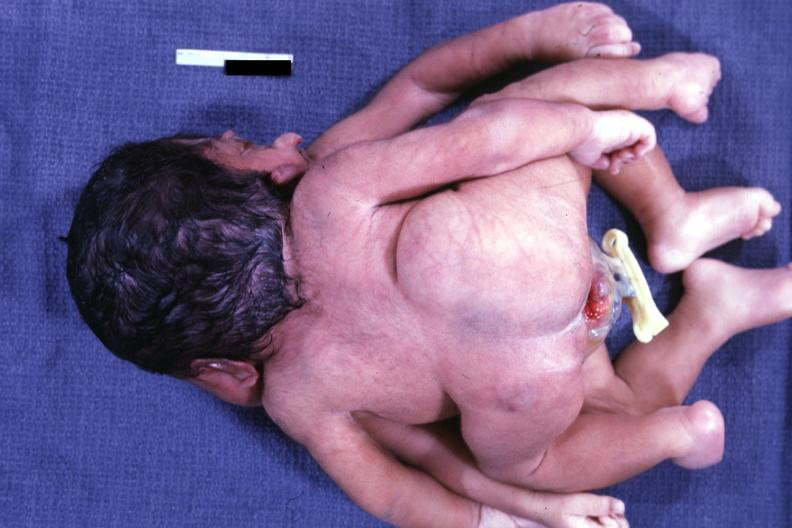what is present?
Answer the question using a single word or phrase. Conjoined twins cephalothoracopagus janiceps 